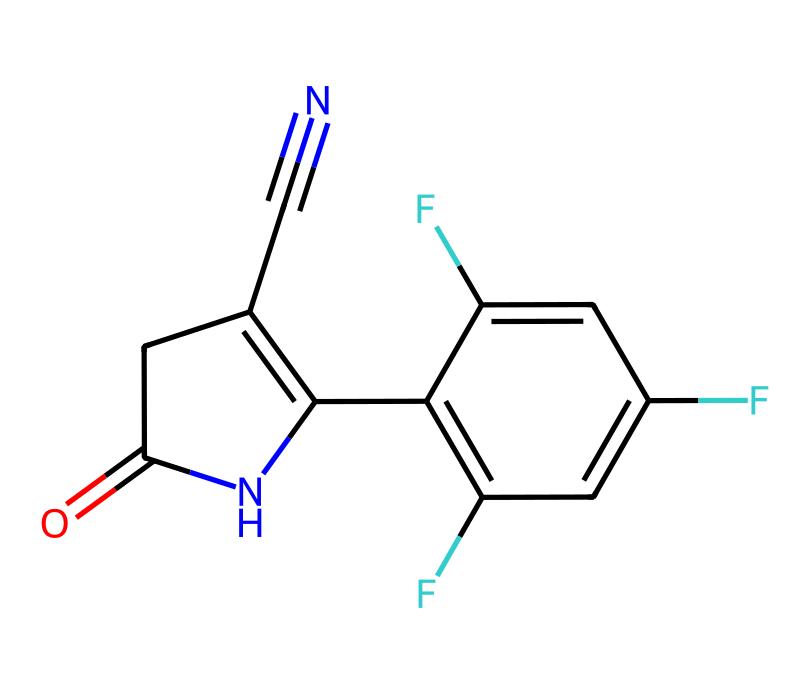What is the functional group present in fludioxonil? The molecular structure contains a carbonyl group (C=O) depicted in the structure, which indicates it has a functional group characteristic of ketones or amides.
Answer: carbonyl group How many fluorine atoms are present in fludioxonil? By inspecting the structure, there are two distinct points which show the presence of fluorine atoms, indicating that there are two fluorines attached to the aromatic ring.
Answer: two What type of chemical is fludioxonil? The structure reveals that fludioxonil has properties of a fungicide, identified primarily through its functional groups and overall structure specifically built to inhibit fungal growth.
Answer: fungicide What is the total number of rings in fludioxonil's structure? Upon examining the structure, one can see two fused rings present, contributing to its complex structure that characteristically aids in its biological function.
Answer: two Which element is primarily responsible for the compound's aromatic properties? The presence of carbon in a cyclic framework with alternating double bonds (as seen in the benzene-like structure) suggests that carbon is the essential element providing aromatic qualities.
Answer: carbon How many nitrogen atoms are there in fludioxonil? The structure includes one nitrogen atom in the cyclic structure and another in the carbon-nitrogen triple bond, totaling two nitrogen atoms in fludioxonil.
Answer: two 